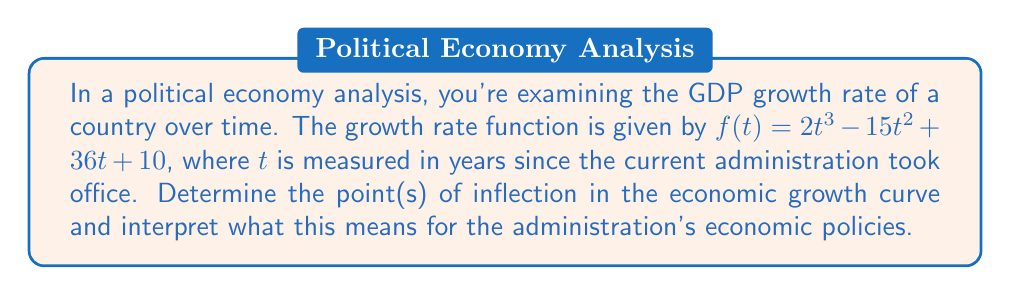What is the answer to this math problem? To solve this problem, we need to follow these steps:

1) First, we need to find the second derivative of the function. This will help us analyze the curvature of the economic growth trend.

   $f(t) = 2t^3 - 15t^2 + 36t + 10$
   $f'(t) = 6t^2 - 30t + 36$
   $f''(t) = 12t - 30$

2) The points of inflection occur where the second derivative equals zero. So, we need to solve:

   $f''(t) = 0$
   $12t - 30 = 0$
   $12t = 30$
   $t = \frac{30}{12} = 2.5$

3) To confirm this is a point of inflection, we need to check if the second derivative changes sign around this point:

   At $t = 2$: $f''(2) = 12(2) - 30 = -6$ (negative)
   At $t = 3$: $f''(3) = 12(3) - 30 = 6$ (positive)

   The second derivative does change sign, confirming this is a point of inflection.

4) To find the y-coordinate of the point of inflection, we substitute $t = 2.5$ into the original function:

   $f(2.5) = 2(2.5)^3 - 15(2.5)^2 + 36(2.5) + 10$
           $= 31.25 - 93.75 + 90 + 10$
           $= 37.5$

5) Interpretation: The point of inflection (2.5, 37.5) represents a change in the curvature of the economic growth trend. Before this point, the growth rate was increasing at a decreasing rate (concave down). After this point, the growth rate starts increasing at an increasing rate (concave up).

   Politically, this could be interpreted as the administration's economic policies taking about 2.5 years to show significant positive effects. The initial slower growth might be attributed to policy implementation and adjustment periods, while the accelerated growth after the inflection point could be seen as these policies starting to bear fruit.
Answer: The point of inflection occurs at (2.5, 37.5). This indicates that the administration's economic policies led to a shift from decelerating to accelerating growth after 2.5 years in office. 